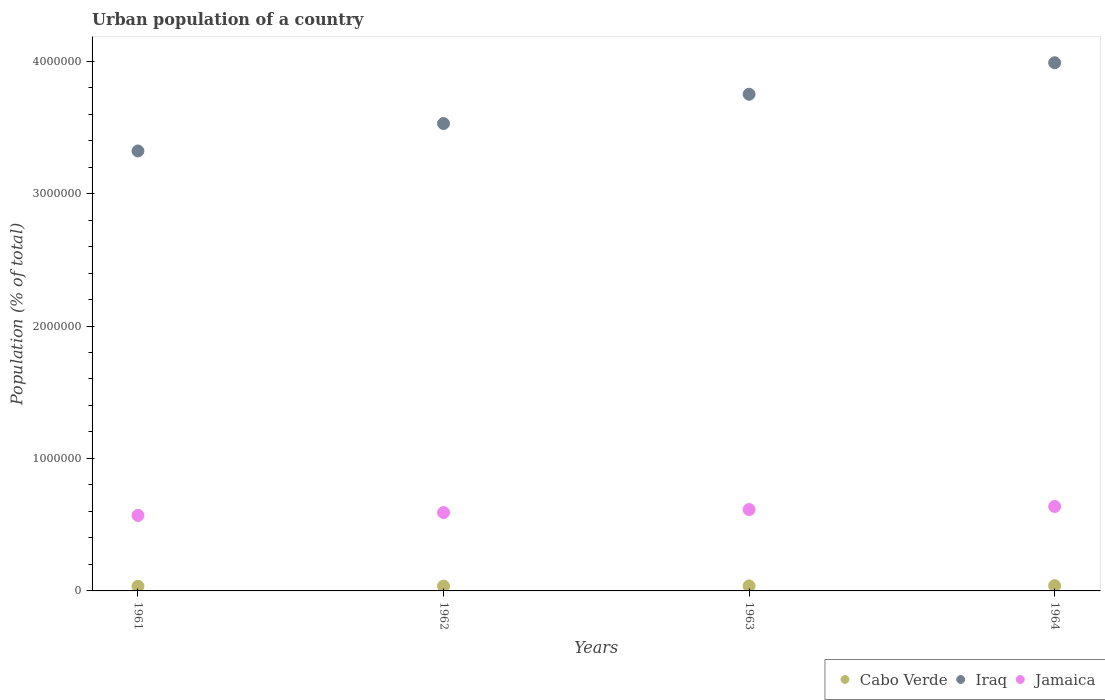What is the urban population in Cabo Verde in 1964?
Keep it short and to the point. 3.98e+04. Across all years, what is the maximum urban population in Jamaica?
Ensure brevity in your answer.  6.37e+05. Across all years, what is the minimum urban population in Iraq?
Keep it short and to the point. 3.32e+06. In which year was the urban population in Iraq maximum?
Give a very brief answer. 1964. What is the total urban population in Cabo Verde in the graph?
Ensure brevity in your answer.  1.49e+05. What is the difference between the urban population in Jamaica in 1961 and that in 1964?
Your answer should be compact. -6.74e+04. What is the difference between the urban population in Jamaica in 1963 and the urban population in Cabo Verde in 1964?
Your response must be concise. 5.74e+05. What is the average urban population in Cabo Verde per year?
Give a very brief answer. 3.73e+04. In the year 1963, what is the difference between the urban population in Jamaica and urban population in Iraq?
Offer a very short reply. -3.14e+06. In how many years, is the urban population in Cabo Verde greater than 2000000 %?
Provide a short and direct response. 0. What is the ratio of the urban population in Jamaica in 1961 to that in 1962?
Your response must be concise. 0.96. Is the urban population in Iraq in 1962 less than that in 1964?
Your answer should be very brief. Yes. What is the difference between the highest and the second highest urban population in Iraq?
Give a very brief answer. 2.38e+05. What is the difference between the highest and the lowest urban population in Jamaica?
Your answer should be very brief. 6.74e+04. In how many years, is the urban population in Iraq greater than the average urban population in Iraq taken over all years?
Your answer should be very brief. 2. Is the sum of the urban population in Jamaica in 1961 and 1962 greater than the maximum urban population in Iraq across all years?
Provide a short and direct response. No. Is it the case that in every year, the sum of the urban population in Jamaica and urban population in Cabo Verde  is greater than the urban population in Iraq?
Provide a succinct answer. No. Is the urban population in Iraq strictly greater than the urban population in Cabo Verde over the years?
Keep it short and to the point. Yes. Does the graph contain any zero values?
Your answer should be compact. No. Does the graph contain grids?
Provide a short and direct response. No. How many legend labels are there?
Keep it short and to the point. 3. What is the title of the graph?
Offer a very short reply. Urban population of a country. What is the label or title of the X-axis?
Give a very brief answer. Years. What is the label or title of the Y-axis?
Provide a succinct answer. Population (% of total). What is the Population (% of total) of Cabo Verde in 1961?
Offer a very short reply. 3.49e+04. What is the Population (% of total) of Iraq in 1961?
Provide a short and direct response. 3.32e+06. What is the Population (% of total) in Jamaica in 1961?
Provide a succinct answer. 5.70e+05. What is the Population (% of total) of Cabo Verde in 1962?
Your answer should be compact. 3.63e+04. What is the Population (% of total) in Iraq in 1962?
Give a very brief answer. 3.53e+06. What is the Population (% of total) of Jamaica in 1962?
Give a very brief answer. 5.91e+05. What is the Population (% of total) of Cabo Verde in 1963?
Make the answer very short. 3.80e+04. What is the Population (% of total) in Iraq in 1963?
Give a very brief answer. 3.75e+06. What is the Population (% of total) of Jamaica in 1963?
Provide a succinct answer. 6.14e+05. What is the Population (% of total) of Cabo Verde in 1964?
Offer a terse response. 3.98e+04. What is the Population (% of total) of Iraq in 1964?
Ensure brevity in your answer.  3.99e+06. What is the Population (% of total) in Jamaica in 1964?
Provide a short and direct response. 6.37e+05. Across all years, what is the maximum Population (% of total) of Cabo Verde?
Your answer should be compact. 3.98e+04. Across all years, what is the maximum Population (% of total) in Iraq?
Provide a short and direct response. 3.99e+06. Across all years, what is the maximum Population (% of total) of Jamaica?
Keep it short and to the point. 6.37e+05. Across all years, what is the minimum Population (% of total) in Cabo Verde?
Offer a terse response. 3.49e+04. Across all years, what is the minimum Population (% of total) of Iraq?
Ensure brevity in your answer.  3.32e+06. Across all years, what is the minimum Population (% of total) in Jamaica?
Provide a short and direct response. 5.70e+05. What is the total Population (% of total) of Cabo Verde in the graph?
Keep it short and to the point. 1.49e+05. What is the total Population (% of total) in Iraq in the graph?
Give a very brief answer. 1.46e+07. What is the total Population (% of total) in Jamaica in the graph?
Your answer should be compact. 2.41e+06. What is the difference between the Population (% of total) in Cabo Verde in 1961 and that in 1962?
Provide a short and direct response. -1414. What is the difference between the Population (% of total) of Iraq in 1961 and that in 1962?
Your answer should be very brief. -2.07e+05. What is the difference between the Population (% of total) in Jamaica in 1961 and that in 1962?
Your answer should be very brief. -2.16e+04. What is the difference between the Population (% of total) of Cabo Verde in 1961 and that in 1963?
Your answer should be very brief. -3060. What is the difference between the Population (% of total) in Iraq in 1961 and that in 1963?
Provide a succinct answer. -4.28e+05. What is the difference between the Population (% of total) in Jamaica in 1961 and that in 1963?
Give a very brief answer. -4.44e+04. What is the difference between the Population (% of total) in Cabo Verde in 1961 and that in 1964?
Keep it short and to the point. -4911. What is the difference between the Population (% of total) of Iraq in 1961 and that in 1964?
Make the answer very short. -6.66e+05. What is the difference between the Population (% of total) of Jamaica in 1961 and that in 1964?
Provide a short and direct response. -6.74e+04. What is the difference between the Population (% of total) in Cabo Verde in 1962 and that in 1963?
Offer a very short reply. -1646. What is the difference between the Population (% of total) of Iraq in 1962 and that in 1963?
Offer a terse response. -2.21e+05. What is the difference between the Population (% of total) of Jamaica in 1962 and that in 1963?
Offer a very short reply. -2.28e+04. What is the difference between the Population (% of total) of Cabo Verde in 1962 and that in 1964?
Offer a terse response. -3497. What is the difference between the Population (% of total) of Iraq in 1962 and that in 1964?
Ensure brevity in your answer.  -4.59e+05. What is the difference between the Population (% of total) in Jamaica in 1962 and that in 1964?
Offer a terse response. -4.59e+04. What is the difference between the Population (% of total) in Cabo Verde in 1963 and that in 1964?
Make the answer very short. -1851. What is the difference between the Population (% of total) in Iraq in 1963 and that in 1964?
Make the answer very short. -2.38e+05. What is the difference between the Population (% of total) in Jamaica in 1963 and that in 1964?
Keep it short and to the point. -2.31e+04. What is the difference between the Population (% of total) of Cabo Verde in 1961 and the Population (% of total) of Iraq in 1962?
Provide a succinct answer. -3.49e+06. What is the difference between the Population (% of total) in Cabo Verde in 1961 and the Population (% of total) in Jamaica in 1962?
Your answer should be very brief. -5.57e+05. What is the difference between the Population (% of total) in Iraq in 1961 and the Population (% of total) in Jamaica in 1962?
Your answer should be compact. 2.73e+06. What is the difference between the Population (% of total) of Cabo Verde in 1961 and the Population (% of total) of Iraq in 1963?
Provide a short and direct response. -3.71e+06. What is the difference between the Population (% of total) of Cabo Verde in 1961 and the Population (% of total) of Jamaica in 1963?
Provide a short and direct response. -5.79e+05. What is the difference between the Population (% of total) of Iraq in 1961 and the Population (% of total) of Jamaica in 1963?
Your answer should be compact. 2.71e+06. What is the difference between the Population (% of total) of Cabo Verde in 1961 and the Population (% of total) of Iraq in 1964?
Provide a succinct answer. -3.95e+06. What is the difference between the Population (% of total) in Cabo Verde in 1961 and the Population (% of total) in Jamaica in 1964?
Provide a succinct answer. -6.02e+05. What is the difference between the Population (% of total) in Iraq in 1961 and the Population (% of total) in Jamaica in 1964?
Give a very brief answer. 2.68e+06. What is the difference between the Population (% of total) in Cabo Verde in 1962 and the Population (% of total) in Iraq in 1963?
Your answer should be very brief. -3.71e+06. What is the difference between the Population (% of total) in Cabo Verde in 1962 and the Population (% of total) in Jamaica in 1963?
Keep it short and to the point. -5.78e+05. What is the difference between the Population (% of total) of Iraq in 1962 and the Population (% of total) of Jamaica in 1963?
Make the answer very short. 2.91e+06. What is the difference between the Population (% of total) of Cabo Verde in 1962 and the Population (% of total) of Iraq in 1964?
Your answer should be compact. -3.95e+06. What is the difference between the Population (% of total) of Cabo Verde in 1962 and the Population (% of total) of Jamaica in 1964?
Provide a short and direct response. -6.01e+05. What is the difference between the Population (% of total) in Iraq in 1962 and the Population (% of total) in Jamaica in 1964?
Ensure brevity in your answer.  2.89e+06. What is the difference between the Population (% of total) in Cabo Verde in 1963 and the Population (% of total) in Iraq in 1964?
Your answer should be very brief. -3.95e+06. What is the difference between the Population (% of total) of Cabo Verde in 1963 and the Population (% of total) of Jamaica in 1964?
Make the answer very short. -5.99e+05. What is the difference between the Population (% of total) in Iraq in 1963 and the Population (% of total) in Jamaica in 1964?
Your answer should be very brief. 3.11e+06. What is the average Population (% of total) in Cabo Verde per year?
Make the answer very short. 3.73e+04. What is the average Population (% of total) in Iraq per year?
Your answer should be compact. 3.65e+06. What is the average Population (% of total) in Jamaica per year?
Keep it short and to the point. 6.03e+05. In the year 1961, what is the difference between the Population (% of total) in Cabo Verde and Population (% of total) in Iraq?
Ensure brevity in your answer.  -3.29e+06. In the year 1961, what is the difference between the Population (% of total) of Cabo Verde and Population (% of total) of Jamaica?
Provide a short and direct response. -5.35e+05. In the year 1961, what is the difference between the Population (% of total) in Iraq and Population (% of total) in Jamaica?
Provide a succinct answer. 2.75e+06. In the year 1962, what is the difference between the Population (% of total) in Cabo Verde and Population (% of total) in Iraq?
Provide a succinct answer. -3.49e+06. In the year 1962, what is the difference between the Population (% of total) of Cabo Verde and Population (% of total) of Jamaica?
Offer a terse response. -5.55e+05. In the year 1962, what is the difference between the Population (% of total) of Iraq and Population (% of total) of Jamaica?
Ensure brevity in your answer.  2.94e+06. In the year 1963, what is the difference between the Population (% of total) of Cabo Verde and Population (% of total) of Iraq?
Provide a short and direct response. -3.71e+06. In the year 1963, what is the difference between the Population (% of total) in Cabo Verde and Population (% of total) in Jamaica?
Keep it short and to the point. -5.76e+05. In the year 1963, what is the difference between the Population (% of total) in Iraq and Population (% of total) in Jamaica?
Keep it short and to the point. 3.14e+06. In the year 1964, what is the difference between the Population (% of total) in Cabo Verde and Population (% of total) in Iraq?
Keep it short and to the point. -3.95e+06. In the year 1964, what is the difference between the Population (% of total) in Cabo Verde and Population (% of total) in Jamaica?
Ensure brevity in your answer.  -5.98e+05. In the year 1964, what is the difference between the Population (% of total) in Iraq and Population (% of total) in Jamaica?
Provide a succinct answer. 3.35e+06. What is the ratio of the Population (% of total) in Cabo Verde in 1961 to that in 1962?
Offer a very short reply. 0.96. What is the ratio of the Population (% of total) of Iraq in 1961 to that in 1962?
Make the answer very short. 0.94. What is the ratio of the Population (% of total) in Jamaica in 1961 to that in 1962?
Give a very brief answer. 0.96. What is the ratio of the Population (% of total) of Cabo Verde in 1961 to that in 1963?
Make the answer very short. 0.92. What is the ratio of the Population (% of total) of Iraq in 1961 to that in 1963?
Ensure brevity in your answer.  0.89. What is the ratio of the Population (% of total) of Jamaica in 1961 to that in 1963?
Offer a very short reply. 0.93. What is the ratio of the Population (% of total) in Cabo Verde in 1961 to that in 1964?
Your response must be concise. 0.88. What is the ratio of the Population (% of total) of Iraq in 1961 to that in 1964?
Provide a succinct answer. 0.83. What is the ratio of the Population (% of total) of Jamaica in 1961 to that in 1964?
Give a very brief answer. 0.89. What is the ratio of the Population (% of total) in Cabo Verde in 1962 to that in 1963?
Ensure brevity in your answer.  0.96. What is the ratio of the Population (% of total) of Iraq in 1962 to that in 1963?
Offer a terse response. 0.94. What is the ratio of the Population (% of total) in Jamaica in 1962 to that in 1963?
Your answer should be very brief. 0.96. What is the ratio of the Population (% of total) in Cabo Verde in 1962 to that in 1964?
Ensure brevity in your answer.  0.91. What is the ratio of the Population (% of total) of Iraq in 1962 to that in 1964?
Your answer should be very brief. 0.88. What is the ratio of the Population (% of total) in Jamaica in 1962 to that in 1964?
Your response must be concise. 0.93. What is the ratio of the Population (% of total) of Cabo Verde in 1963 to that in 1964?
Provide a short and direct response. 0.95. What is the ratio of the Population (% of total) of Iraq in 1963 to that in 1964?
Ensure brevity in your answer.  0.94. What is the ratio of the Population (% of total) in Jamaica in 1963 to that in 1964?
Keep it short and to the point. 0.96. What is the difference between the highest and the second highest Population (% of total) in Cabo Verde?
Ensure brevity in your answer.  1851. What is the difference between the highest and the second highest Population (% of total) of Iraq?
Make the answer very short. 2.38e+05. What is the difference between the highest and the second highest Population (% of total) of Jamaica?
Ensure brevity in your answer.  2.31e+04. What is the difference between the highest and the lowest Population (% of total) in Cabo Verde?
Offer a terse response. 4911. What is the difference between the highest and the lowest Population (% of total) of Iraq?
Provide a succinct answer. 6.66e+05. What is the difference between the highest and the lowest Population (% of total) of Jamaica?
Your answer should be very brief. 6.74e+04. 